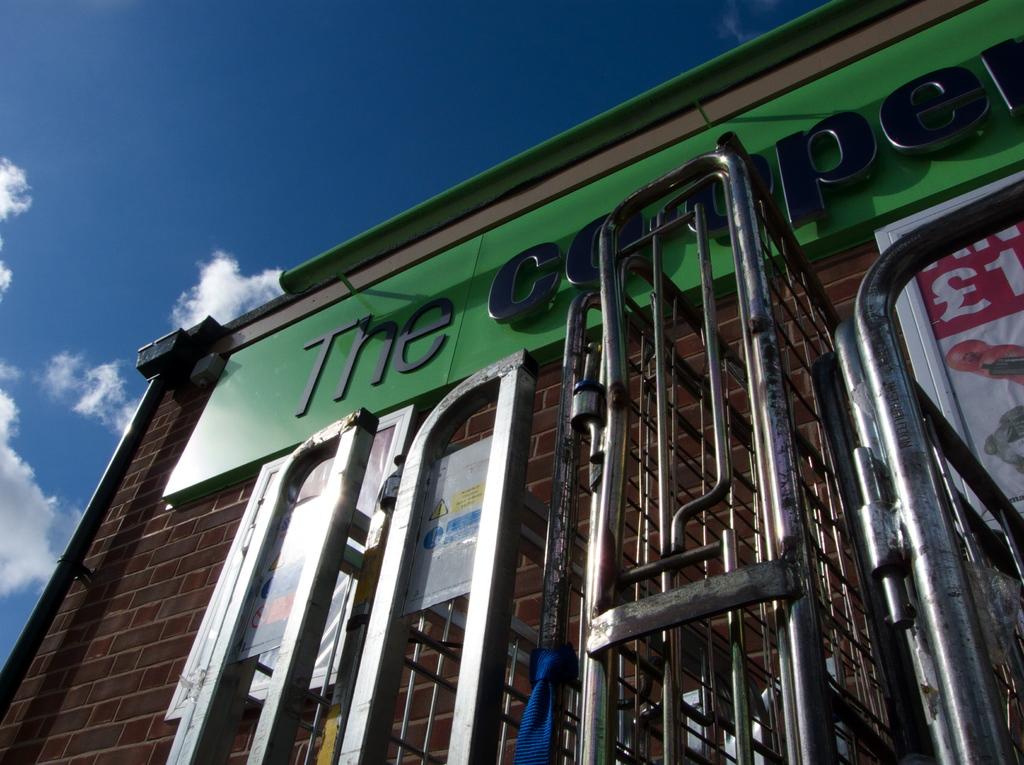What's word starts the title of the building?
Provide a short and direct response. The. 